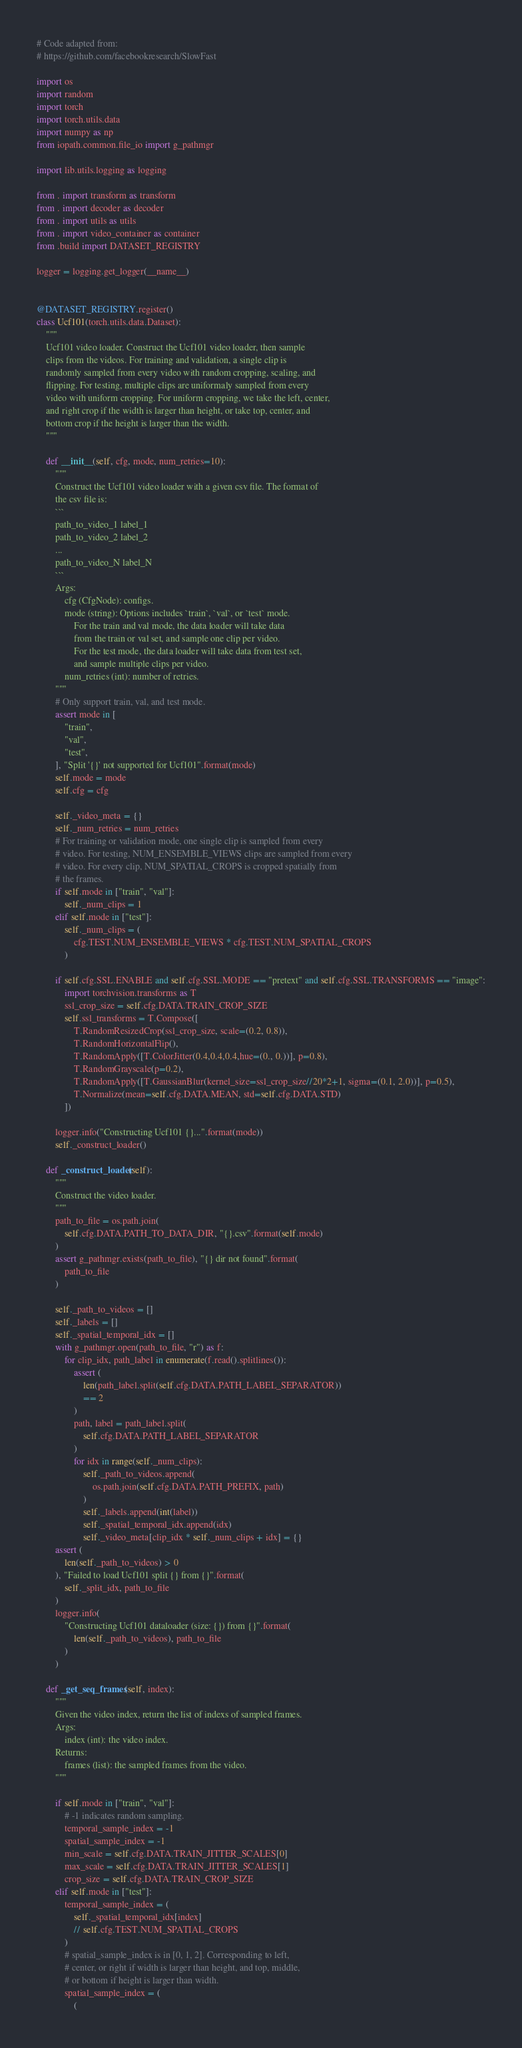<code> <loc_0><loc_0><loc_500><loc_500><_Python_># Code adapted from:
# https://github.com/facebookresearch/SlowFast

import os
import random
import torch
import torch.utils.data
import numpy as np
from iopath.common.file_io import g_pathmgr

import lib.utils.logging as logging

from . import transform as transform
from . import decoder as decoder
from . import utils as utils
from . import video_container as container
from .build import DATASET_REGISTRY

logger = logging.get_logger(__name__)


@DATASET_REGISTRY.register()
class Ucf101(torch.utils.data.Dataset):
    """
    Ucf101 video loader. Construct the Ucf101 video loader, then sample
    clips from the videos. For training and validation, a single clip is
    randomly sampled from every video with random cropping, scaling, and
    flipping. For testing, multiple clips are uniformaly sampled from every
    video with uniform cropping. For uniform cropping, we take the left, center,
    and right crop if the width is larger than height, or take top, center, and
    bottom crop if the height is larger than the width.
    """

    def __init__(self, cfg, mode, num_retries=10):
        """
        Construct the Ucf101 video loader with a given csv file. The format of
        the csv file is:
        ```
        path_to_video_1 label_1
        path_to_video_2 label_2
        ...
        path_to_video_N label_N
        ```
        Args:
            cfg (CfgNode): configs.
            mode (string): Options includes `train`, `val`, or `test` mode.
                For the train and val mode, the data loader will take data
                from the train or val set, and sample one clip per video.
                For the test mode, the data loader will take data from test set,
                and sample multiple clips per video.
            num_retries (int): number of retries.
        """
        # Only support train, val, and test mode.
        assert mode in [
            "train",
            "val",
            "test",
        ], "Split '{}' not supported for Ucf101".format(mode)
        self.mode = mode
        self.cfg = cfg

        self._video_meta = {}
        self._num_retries = num_retries
        # For training or validation mode, one single clip is sampled from every
        # video. For testing, NUM_ENSEMBLE_VIEWS clips are sampled from every
        # video. For every clip, NUM_SPATIAL_CROPS is cropped spatially from
        # the frames.
        if self.mode in ["train", "val"]:
            self._num_clips = 1
        elif self.mode in ["test"]:
            self._num_clips = (
                cfg.TEST.NUM_ENSEMBLE_VIEWS * cfg.TEST.NUM_SPATIAL_CROPS
            )
        
        if self.cfg.SSL.ENABLE and self.cfg.SSL.MODE == "pretext" and self.cfg.SSL.TRANSFORMS == "image":
            import torchvision.transforms as T
            ssl_crop_size = self.cfg.DATA.TRAIN_CROP_SIZE
            self.ssl_transforms = T.Compose([
                T.RandomResizedCrop(ssl_crop_size, scale=(0.2, 0.8)),
                T.RandomHorizontalFlip(),
                T.RandomApply([T.ColorJitter(0.4,0.4,0.4,hue=(0., 0.))], p=0.8),
                T.RandomGrayscale(p=0.2),
                T.RandomApply([T.GaussianBlur(kernel_size=ssl_crop_size//20*2+1, sigma=(0.1, 2.0))], p=0.5),
                T.Normalize(mean=self.cfg.DATA.MEAN, std=self.cfg.DATA.STD)
            ])

        logger.info("Constructing Ucf101 {}...".format(mode))
        self._construct_loader()

    def _construct_loader(self):
        """
        Construct the video loader.
        """
        path_to_file = os.path.join(
            self.cfg.DATA.PATH_TO_DATA_DIR, "{}.csv".format(self.mode)
        )
        assert g_pathmgr.exists(path_to_file), "{} dir not found".format(
            path_to_file
        )

        self._path_to_videos = []
        self._labels = []
        self._spatial_temporal_idx = []
        with g_pathmgr.open(path_to_file, "r") as f:
            for clip_idx, path_label in enumerate(f.read().splitlines()):
                assert (
                    len(path_label.split(self.cfg.DATA.PATH_LABEL_SEPARATOR))
                    == 2
                )
                path, label = path_label.split(
                    self.cfg.DATA.PATH_LABEL_SEPARATOR
                )
                for idx in range(self._num_clips):
                    self._path_to_videos.append(
                        os.path.join(self.cfg.DATA.PATH_PREFIX, path)
                    )
                    self._labels.append(int(label))
                    self._spatial_temporal_idx.append(idx)
                    self._video_meta[clip_idx * self._num_clips + idx] = {}
        assert (
            len(self._path_to_videos) > 0
        ), "Failed to load Ucf101 split {} from {}".format(
            self._split_idx, path_to_file
        )
        logger.info(
            "Constructing Ucf101 dataloader (size: {}) from {}".format(
                len(self._path_to_videos), path_to_file
            )
        )

    def _get_seq_frames(self, index):
        """
        Given the video index, return the list of indexs of sampled frames.
        Args:
            index (int): the video index.
        Returns:
            frames (list): the sampled frames from the video.
        """

        if self.mode in ["train", "val"]:
            # -1 indicates random sampling.
            temporal_sample_index = -1
            spatial_sample_index = -1
            min_scale = self.cfg.DATA.TRAIN_JITTER_SCALES[0]
            max_scale = self.cfg.DATA.TRAIN_JITTER_SCALES[1]
            crop_size = self.cfg.DATA.TRAIN_CROP_SIZE
        elif self.mode in ["test"]:
            temporal_sample_index = (
                self._spatial_temporal_idx[index]
                // self.cfg.TEST.NUM_SPATIAL_CROPS
            )
            # spatial_sample_index is in [0, 1, 2]. Corresponding to left,
            # center, or right if width is larger than height, and top, middle,
            # or bottom if height is larger than width.
            spatial_sample_index = (
                (</code> 